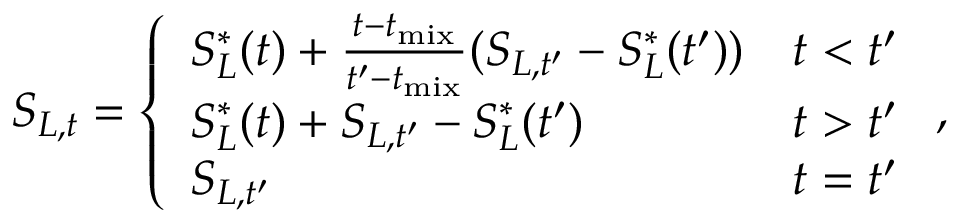<formula> <loc_0><loc_0><loc_500><loc_500>S _ { L , t } = \left \{ \begin{array} { l l } { S _ { L } ^ { \ast } ( t ) + \frac { t - t _ { m i x } } { t ^ { \prime } - t _ { m i x } } ( S _ { L , t ^ { \prime } } - S _ { L } ^ { \ast } ( t ^ { \prime } ) ) } & { t < t ^ { \prime } } \\ { S _ { L } ^ { \ast } ( t ) + S _ { L , t ^ { \prime } } - S _ { L } ^ { \ast } ( t ^ { \prime } ) } & { t > t ^ { \prime } } \\ { S _ { L , t ^ { \prime } } } & { t = t ^ { \prime } } \end{array} ,</formula> 